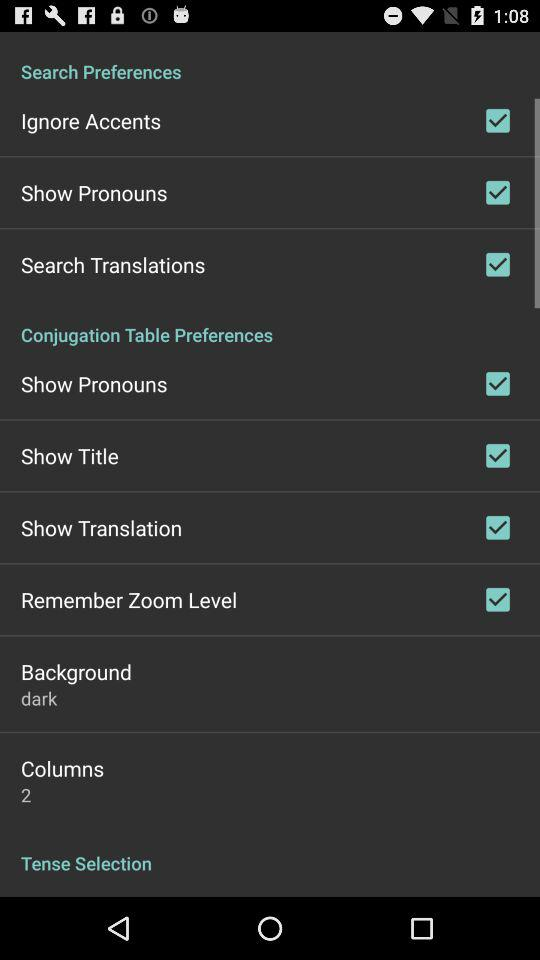Which type of background is selected? The selected background type is dark. 